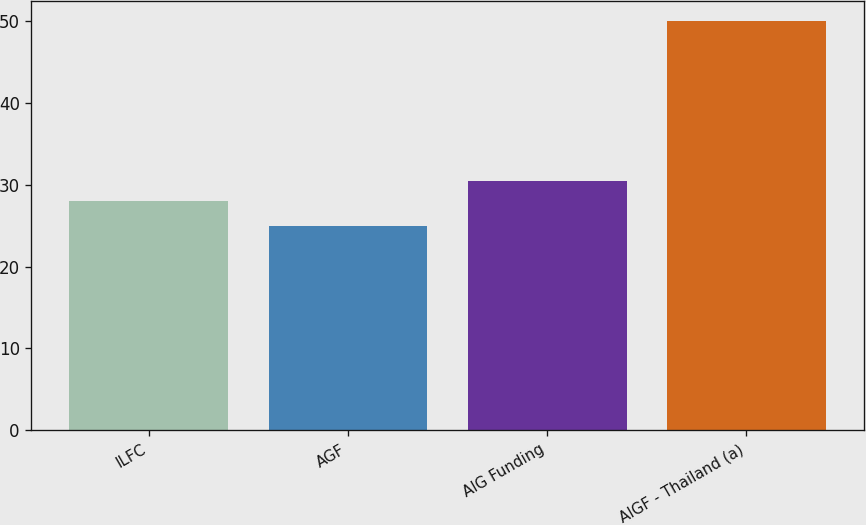Convert chart. <chart><loc_0><loc_0><loc_500><loc_500><bar_chart><fcel>ILFC<fcel>AGF<fcel>AIG Funding<fcel>AIGF - Thailand (a)<nl><fcel>28<fcel>25<fcel>30.5<fcel>50<nl></chart> 